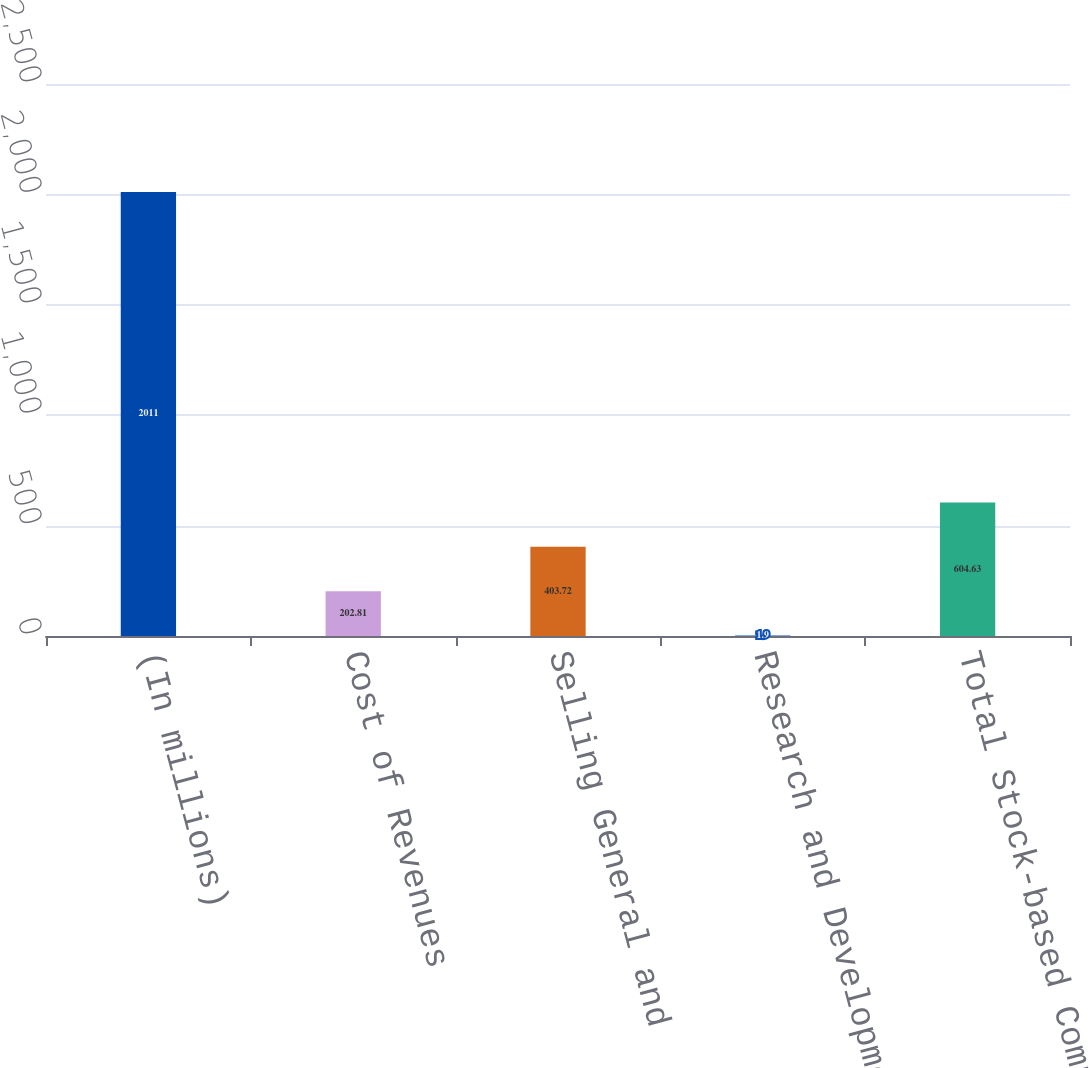Convert chart. <chart><loc_0><loc_0><loc_500><loc_500><bar_chart><fcel>(In millions)<fcel>Cost of Revenues<fcel>Selling General and<fcel>Research and Development<fcel>Total Stock-based Compensation<nl><fcel>2011<fcel>202.81<fcel>403.72<fcel>1.9<fcel>604.63<nl></chart> 